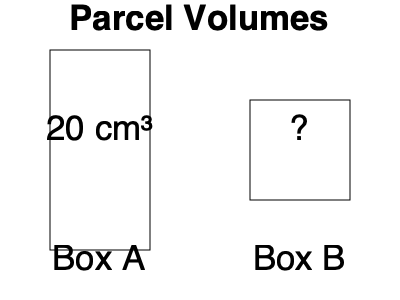As a supportive manager, you want to help your mail carrier estimate parcel volumes quickly. Box A has a volume of 20 cm³. If Box B has the same height as Box A but half the width and depth, what is the volume of Box B in cm³? To solve this problem, let's follow these steps:

1) First, we need to understand the relationship between Box A and Box B:
   - Box B has the same height as Box A
   - Box B has half the width of Box A
   - Box B has half the depth of Box A

2) Let's define the dimensions of Box A:
   - Volume of Box A = 20 cm³
   - Let the dimensions be length (l), width (w), and height (h)
   - So, $l \times w \times h = 20$

3) Now, for Box B:
   - Height is the same as Box A: h
   - Width is half of Box A: $\frac{w}{2}$
   - Depth is half of Box A: $\frac{l}{2}$

4) The volume of Box B will be:
   $\frac{l}{2} \times \frac{w}{2} \times h$

5) This can be rewritten as:
   $\frac{1}{4} \times (l \times w \times h)$

6) We know that $l \times w \times h = 20$ for Box A, so for Box B:
   $\frac{1}{4} \times 20 = 5$

Therefore, the volume of Box B is 5 cm³.
Answer: 5 cm³ 